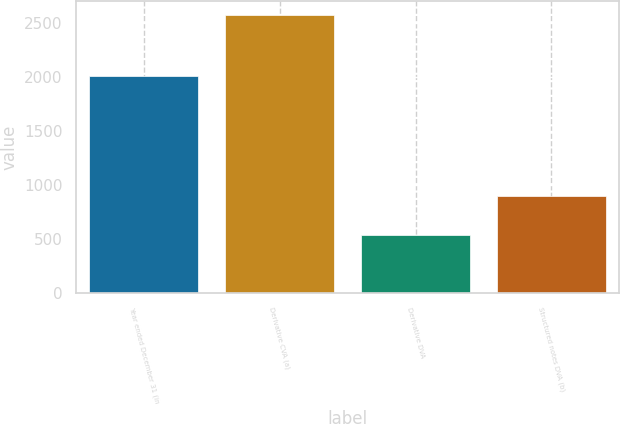Convert chart. <chart><loc_0><loc_0><loc_500><loc_500><bar_chart><fcel>Year ended December 31 (in<fcel>Derivative CVA (a)<fcel>Derivative DVA<fcel>Structured notes DVA (b)<nl><fcel>2011<fcel>2574<fcel>538<fcel>899<nl></chart> 